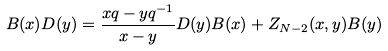<formula> <loc_0><loc_0><loc_500><loc_500>& B ( x ) D ( y ) = \frac { x q - y q ^ { - 1 } } { x - y } D ( y ) B ( x ) + Z _ { N - 2 } ( x , y ) B ( y )</formula> 